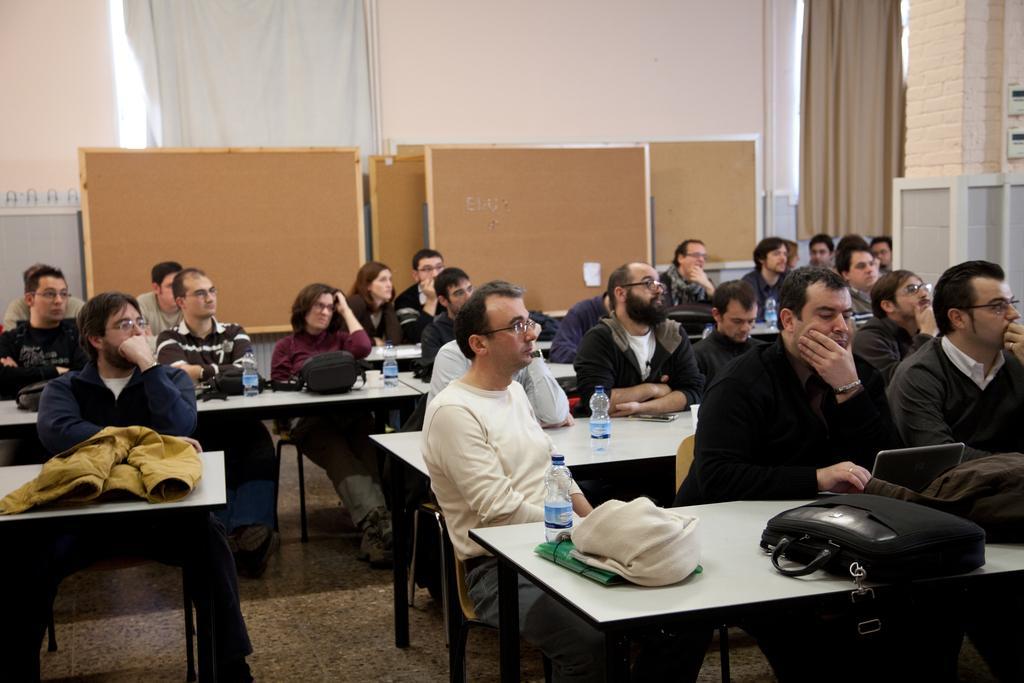Describe this image in one or two sentences. In the image few people are sitting on a chairs. In front of them are some tables on the table there are some water bottles and bags. 